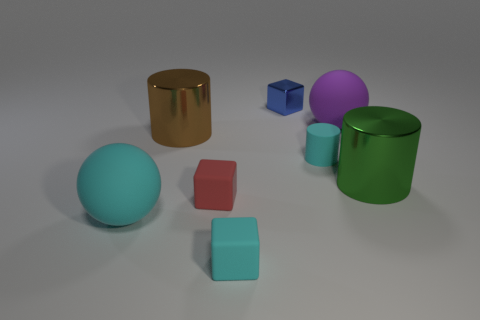Subtract all matte blocks. How many blocks are left? 1 Subtract 1 cylinders. How many cylinders are left? 2 Add 2 purple things. How many objects exist? 10 Subtract all balls. How many objects are left? 6 Add 6 small red matte blocks. How many small red matte blocks are left? 7 Add 2 tiny rubber blocks. How many tiny rubber blocks exist? 4 Subtract 1 cyan balls. How many objects are left? 7 Subtract all purple metal objects. Subtract all red matte things. How many objects are left? 7 